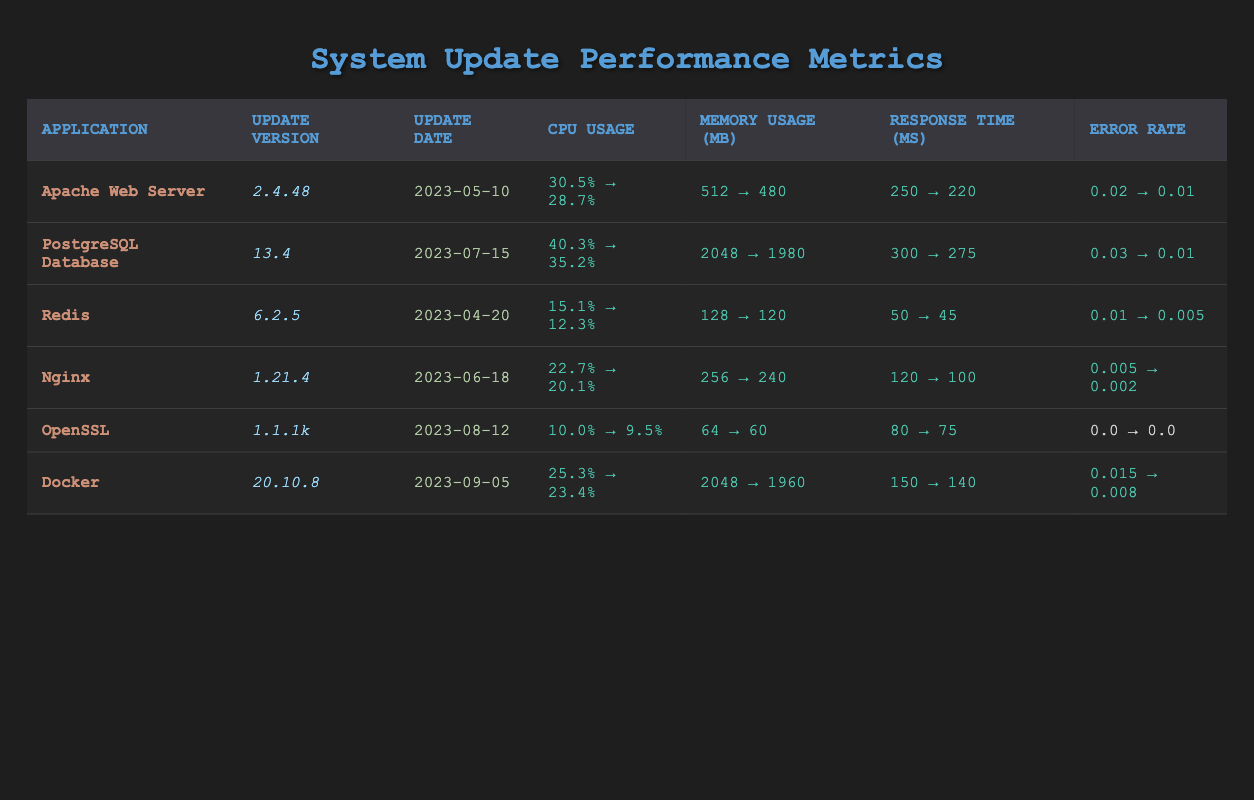What is the CPU usage after the update for PostgreSQL Database? The table shows that the CPU usage after the update for PostgreSQL Database is 35.2%.
Answer: 35.2% What was the error rate before the update for the Apache Web Server? The table indicates that the error rate before the update for the Apache Web Server was 0.02.
Answer: 0.02 Which application had the highest memory usage before the update? Comparing the memory usage before the update, PostgreSQL Database had the highest value at 2048 MB.
Answer: PostgreSQL Database What is the decrease in CPU usage after the update for Nginx? The CPU usage before the update was 22.7%, and it decreased to 20.1%. Thus, the decrease is 22.7% - 20.1% = 2.6%.
Answer: 2.6% What was the response time improvement for Docker? The response time before the update was 150 ms, and after the update, it was 140 ms. The improvement is 150 ms - 140 ms = 10 ms.
Answer: 10 ms Did OpenSSL have any changes in its error rate after the update? Both before and after the update, the error rate for OpenSSL remains at 0.0, indicating no changes.
Answer: No Which application had the greatest reduction in response time? Analyzing the response time, Apache Web Server had a reduction from 250 ms to 220 ms (30 ms), which is the greatest reduction compared to others.
Answer: Apache Web Server What is the average CPU usage before the updates for all applications? Summing the CPU usage before the updates gives 30.5 + 40.3 + 15.1 + 22.7 + 10.0 + 25.3 = 143.9. With 6 applications, the average is 143.9/6 = 23.98.
Answer: 23.98 How many applications had a decreased error rate after the update? The error rates decreased for all applications except OpenSSL, which had no error rate. Therefore, that accounts for 5 applications having decreased error rates.
Answer: 5 What is the difference in memory usage before and after the updates for Redis? The memory usage before the update was 128 MB, which decreased to 120 MB. The difference is 128 - 120 = 8 MB.
Answer: 8 MB 